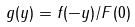<formula> <loc_0><loc_0><loc_500><loc_500>g ( y ) = f ( - y ) / F ( 0 )</formula> 